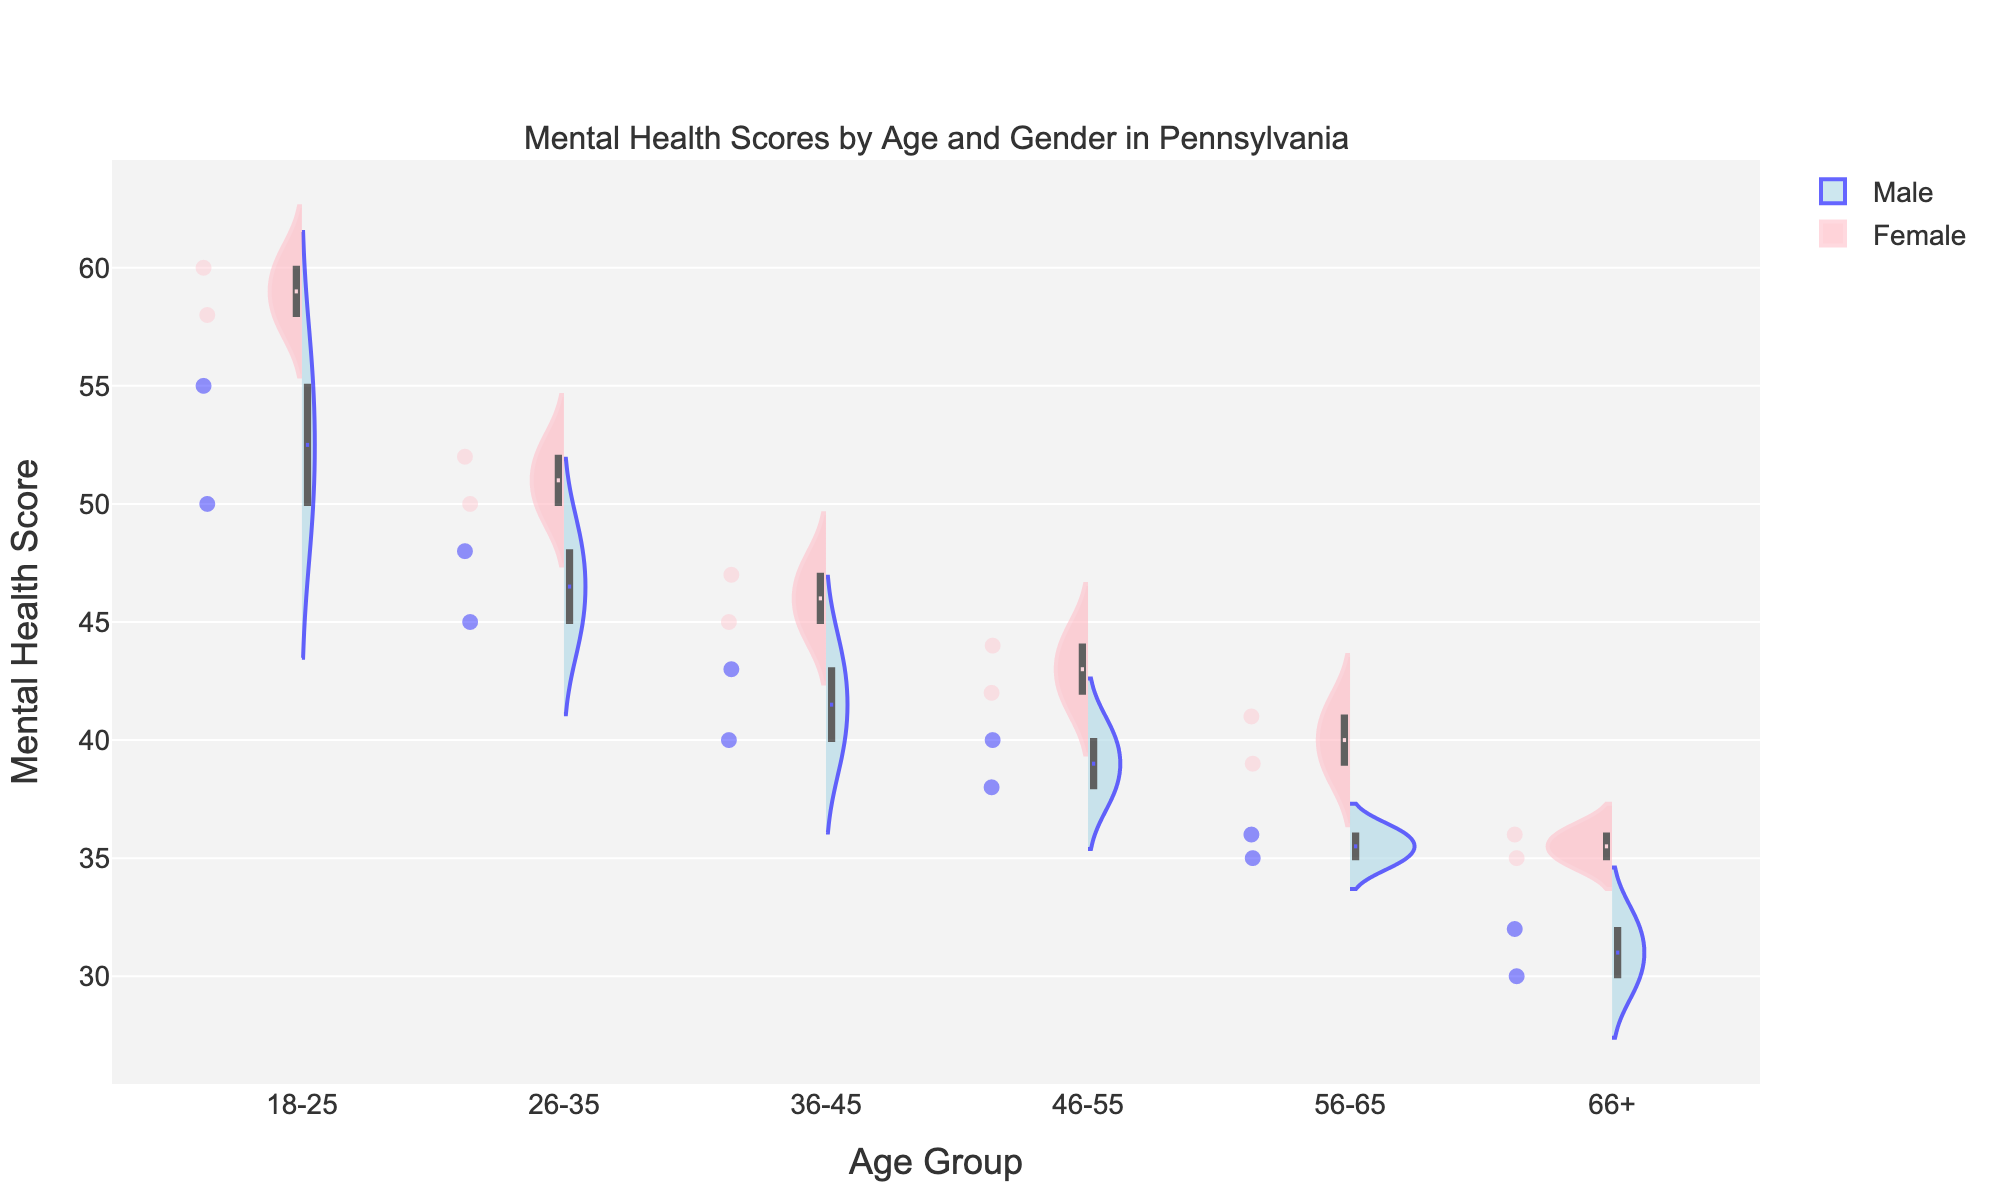What is the title of the chart? The title is usually located at the top of the figure. The title here reads: "Mental Health Scores by Age and Gender in Pennsylvania".
Answer: Mental Health Scores by Age and Gender in Pennsylvania What age groups are represented on the x-axis? To find the age groups, look at the labels along the x-axis. The groups are broken down into categories which include: "18-25", "26-35", "36-45", "46-55", "56-65", "66+".
Answer: 18-25, 26-35, 36-45, 46-55, 56-65, 66+ Which gender shows a higher median mental health score in the 18-25 age group? To determine the median score, look for the horizontal line inside the violin plot for each gender in the 18-25 age group. The female group has a horizontal line higher than the male group.
Answer: Female How does the shape of the violin plot for males compare to females in the 66+ age group? Examine both violin plots in the 66+ age group for males and females. The violin plot for males is narrower and closer to the bottom, while the female plot is wider and higher.
Answer: Males: narrower and lower, Females: wider and higher Are the scores more spread out for males or females in the 46-55 age group? Compare the widths of the male and female violin plots in the 46-55 age group. The width of the female plot indicates more spread, as it spans a larger range of values.
Answer: Females Which age group shows the smallest difference in median mental health scores between males and females? Look for the age group where the horizontal lines (medians) in both the male and female plots are the closest to each other. This is most evident in the 66+ age group.
Answer: 66+ What is the overall trend in mental health scores for both genders as age increases? Observe how the violin plots change from youngest to oldest age groups. Both male and female scores generally decrease as age increases.
Answer: Decreasing trend Which gender has a higher variance in mental health scores in the 56-65 age group? Examine the spread of the violin plots for the 56-65 age group. The female plot is wider, indicating higher variance.
Answer: Females What colors represent males and females in the chart? Check the color of the violin plots and the legend. Males are represented by light blue, and females by light pink.
Answer: Males: light blue, Females: light pink Which age group has the highest median mental health score overall? Look for the highest horizontal line in all age groups. The 18-25 age group has the highest medians for both genders.
Answer: 18-25 